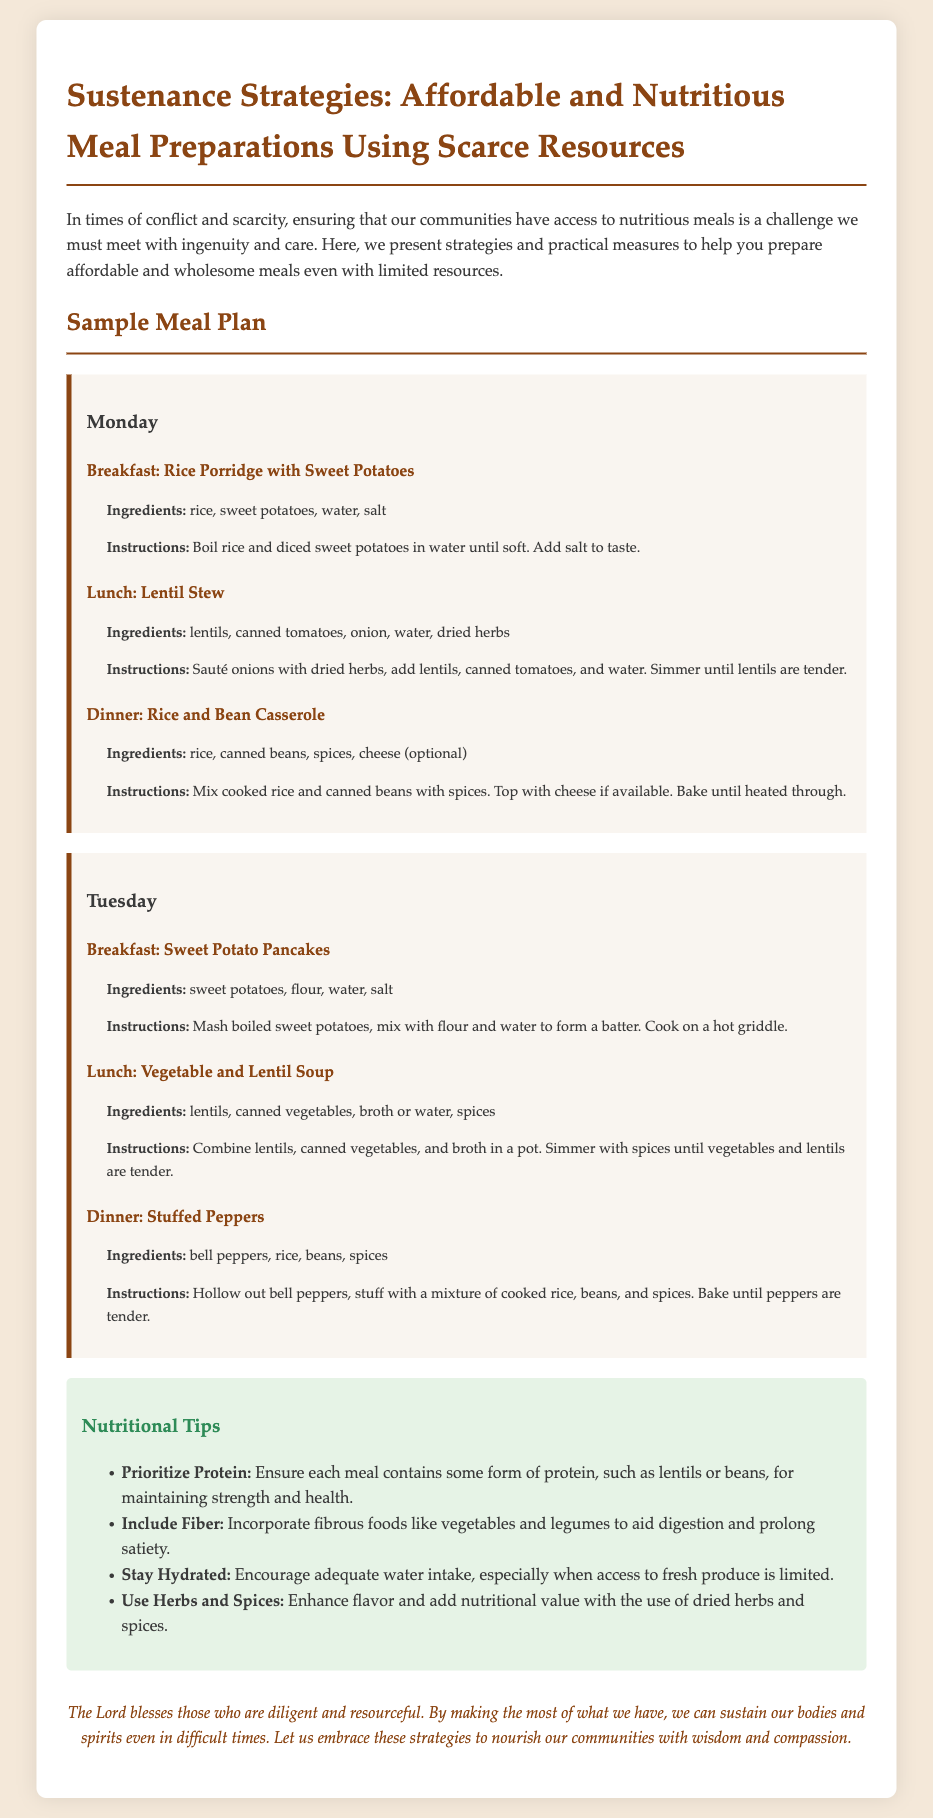What is the title of the document? The title is explicitly stated at the beginning of the document.
Answer: Sustenance Strategies: Affordable and Nutritious Meal Preparations Using Scarce Resources How many meals are listed for Monday? The document outlines the meal plan for Monday, which includes breakfast, lunch, and dinner.
Answer: 3 What is the main ingredient in the breakfast for Tuesday? The breakfast for Tuesday is specified, highlighting sweet potatoes as the primary ingredient.
Answer: Sweet potatoes What type of soup is included for lunch on Tuesday? The specific meal listed for lunch on Tuesday is a types of soup, which requires reasoning over the lunch section.
Answer: Vegetable and Lentil Soup What is one of the nutritional tips provided? The document lists various nutritional tips to aid meal preparation, and this question assesses the understanding of these tips.
Answer: Prioritize Protein How are the stuffed peppers prepared? The preparation method for stuffed peppers is detailed in the dinner section for Tuesday.
Answer: Bake until peppers are tender Which day includes Rice and Bean Casserole for dinner? The meal plan specifies the dinner meals by day; this asks for the identification of the correct day for a specific meal.
Answer: Monday 